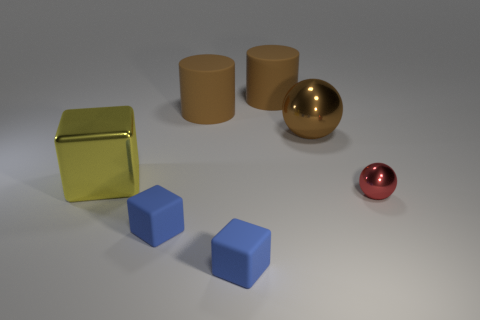What material is the ball that is in front of the yellow metallic cube?
Ensure brevity in your answer.  Metal. What number of other tiny objects are the same color as the tiny metal thing?
Offer a terse response. 0. There is a ball that is made of the same material as the small red object; what size is it?
Your response must be concise. Large. What number of objects are yellow shiny objects or metallic objects?
Provide a succinct answer. 3. What is the color of the metallic thing right of the brown sphere?
Offer a very short reply. Red. There is another shiny thing that is the same shape as the red object; what size is it?
Your answer should be compact. Large. What number of things are blocks behind the small shiny ball or balls that are behind the big yellow cube?
Provide a short and direct response. 2. What is the size of the shiny object that is both on the right side of the big yellow metallic cube and behind the red metallic thing?
Your answer should be compact. Large. Do the large brown metallic object and the shiny object that is in front of the big yellow shiny cube have the same shape?
Provide a succinct answer. Yes. How many objects are metal things that are left of the red shiny thing or red spheres?
Make the answer very short. 3. 